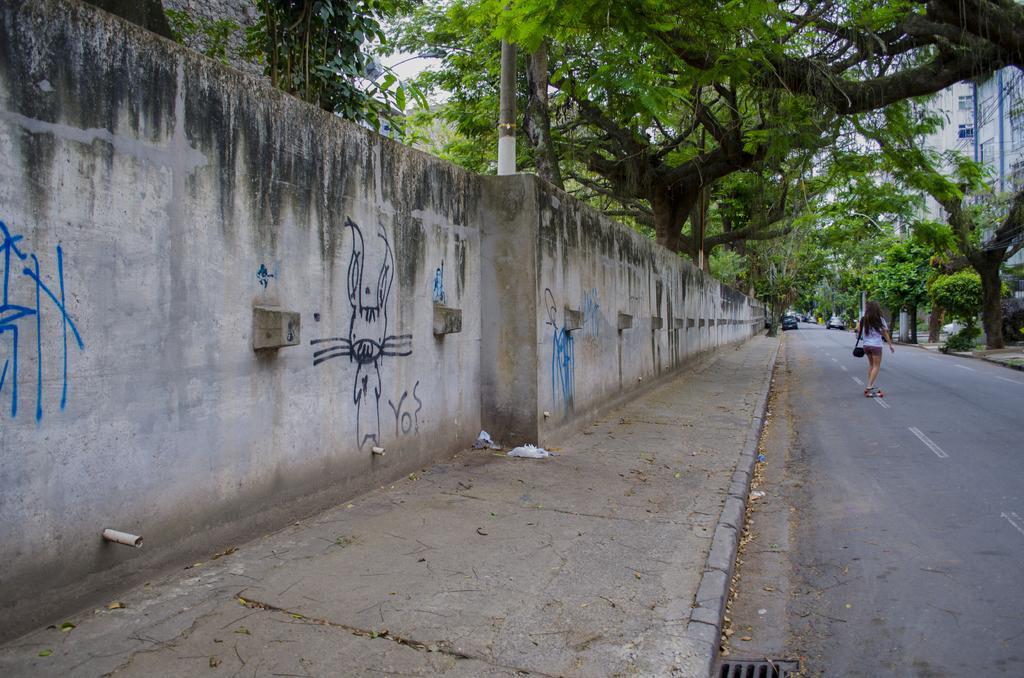Describe this image in one or two sentences. In this image there is a road on that road a women is skating, on either side of the road there is a footpath, in the left side footpath there is wall, beside the wall there are trees, in the right side there are trees and buildings. 